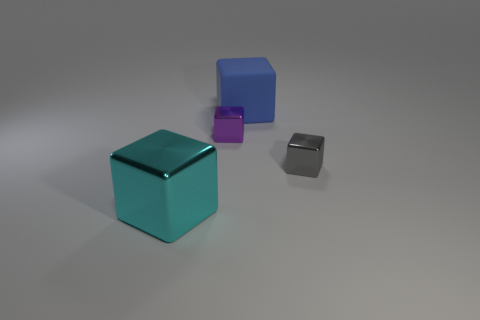Do the cyan metallic object and the object that is behind the purple thing have the same size?
Keep it short and to the point. Yes. There is a small shiny cube that is on the left side of the small gray metal thing; is there a blue object in front of it?
Offer a terse response. No. Is there another cyan object that has the same shape as the matte thing?
Your answer should be very brief. Yes. How many matte objects are in front of the tiny shiny block that is to the left of the tiny thing that is on the right side of the big blue rubber object?
Provide a short and direct response. 0. Does the large rubber cube have the same color as the small metallic cube that is to the right of the large matte thing?
Provide a short and direct response. No. What number of objects are either objects on the left side of the tiny purple object or small cubes that are left of the rubber cube?
Provide a short and direct response. 2. Are there more rubber things on the left side of the blue matte block than large cyan shiny cubes behind the cyan shiny object?
Your answer should be very brief. No. What material is the tiny object behind the tiny metallic object that is in front of the small block that is behind the small gray metallic block?
Your response must be concise. Metal. Is the shape of the small shiny object that is left of the gray thing the same as the large thing that is in front of the tiny gray object?
Ensure brevity in your answer.  Yes. Is there a gray shiny block that has the same size as the blue thing?
Your answer should be very brief. No. 